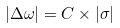Convert formula to latex. <formula><loc_0><loc_0><loc_500><loc_500>| \Delta \omega | = C \times | \sigma |</formula> 